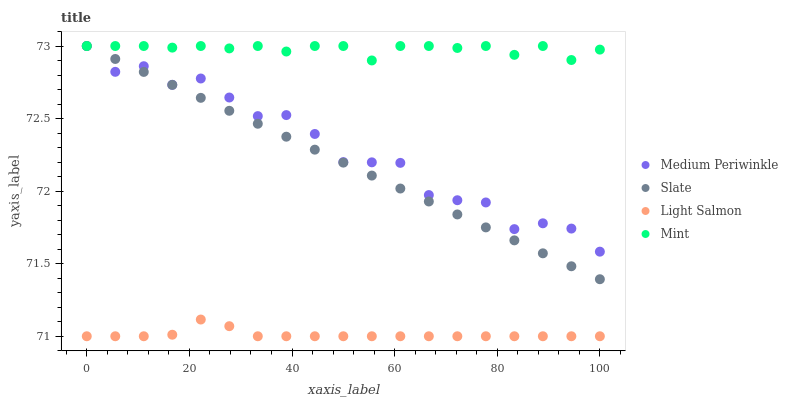Does Light Salmon have the minimum area under the curve?
Answer yes or no. Yes. Does Mint have the maximum area under the curve?
Answer yes or no. Yes. Does Slate have the minimum area under the curve?
Answer yes or no. No. Does Slate have the maximum area under the curve?
Answer yes or no. No. Is Slate the smoothest?
Answer yes or no. Yes. Is Medium Periwinkle the roughest?
Answer yes or no. Yes. Is Medium Periwinkle the smoothest?
Answer yes or no. No. Is Slate the roughest?
Answer yes or no. No. Does Light Salmon have the lowest value?
Answer yes or no. Yes. Does Slate have the lowest value?
Answer yes or no. No. Does Medium Periwinkle have the highest value?
Answer yes or no. Yes. Does Light Salmon have the highest value?
Answer yes or no. No. Is Light Salmon less than Medium Periwinkle?
Answer yes or no. Yes. Is Medium Periwinkle greater than Light Salmon?
Answer yes or no. Yes. Does Slate intersect Mint?
Answer yes or no. Yes. Is Slate less than Mint?
Answer yes or no. No. Is Slate greater than Mint?
Answer yes or no. No. Does Light Salmon intersect Medium Periwinkle?
Answer yes or no. No. 